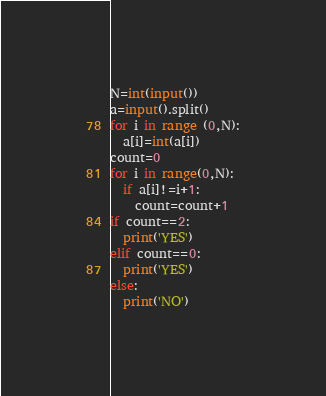<code> <loc_0><loc_0><loc_500><loc_500><_Python_>N=int(input())
a=input().split()
for i in range (0,N):
  a[i]=int(a[i])
count=0
for i in range(0,N):
  if a[i]!=i+1:
    count=count+1
if count==2:
  print('YES')
elif count==0:
  print('YES')
else:
  print('NO')</code> 